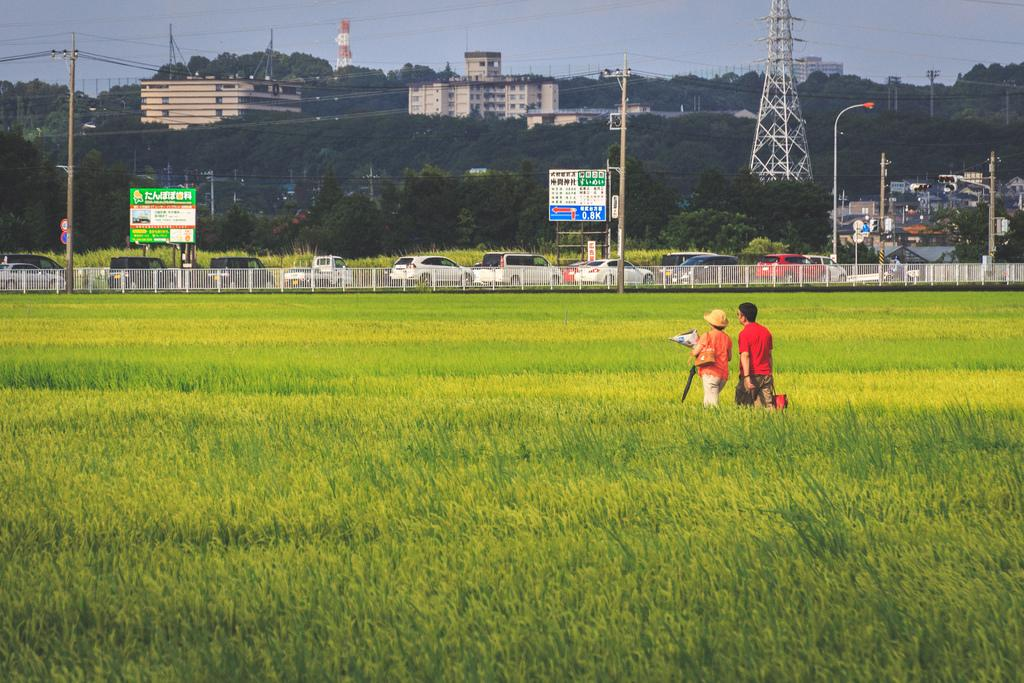What are the two people holding in the image? The information provided does not specify what the two people are holding. What can be seen in the background of the image? In the background, there are vehicles, trees, boards, poles, light poles, buildings, fencing, and wires. What is the color of the grass in the foreground? The grass in the foreground is green. What type of fear is depicted in the image? There is no fear depicted in the image; it features two people holding something and various background elements. What religion is represented by the objects in the image? There is no indication of any religious symbols or themes in the image. 